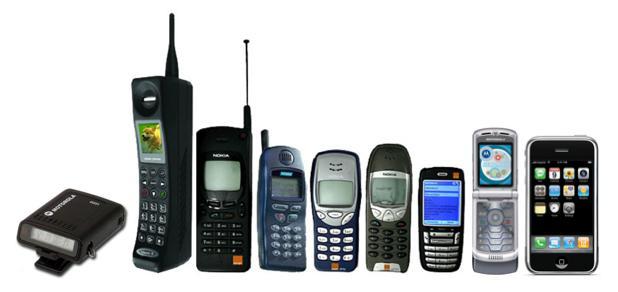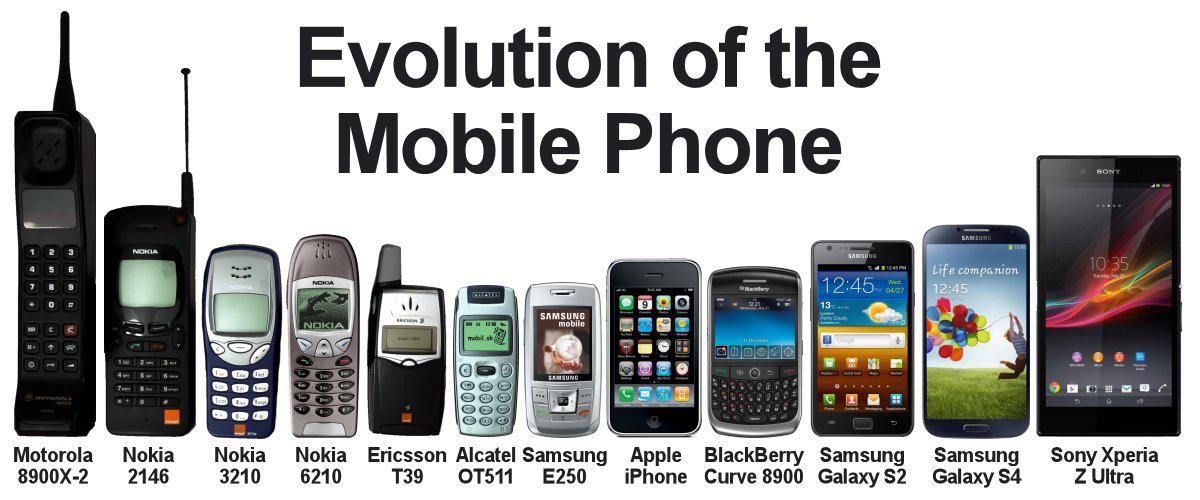The first image is the image on the left, the second image is the image on the right. For the images shown, is this caption "At least one phone is upright next to a box." true? Answer yes or no. No. 